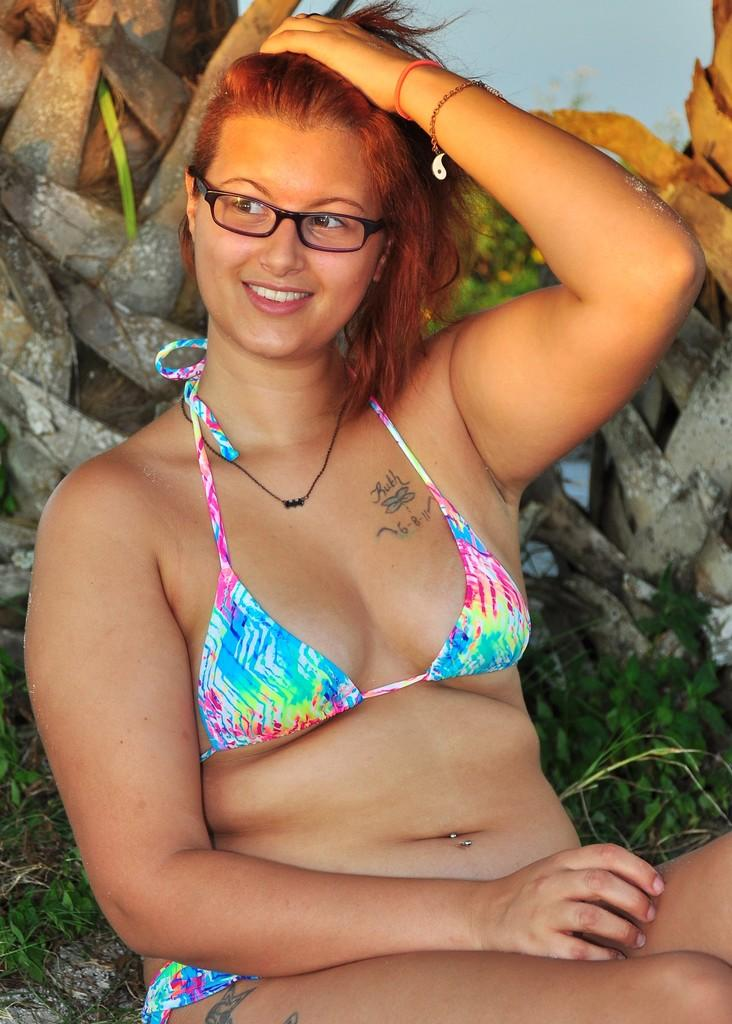Who is present in the image? There is a woman in the image. What is the woman's facial expression? The woman is smiling. What accessory is the woman wearing? The woman is wearing spectacles. What can be seen in the background of the image? There is a trunk of trees visible in the background of the image. What type of territory is the woman claiming in the image? There is no indication in the image that the woman is claiming any territory. Is the woman playing baseball in the image? There is no baseball or any related equipment visible in the image. 